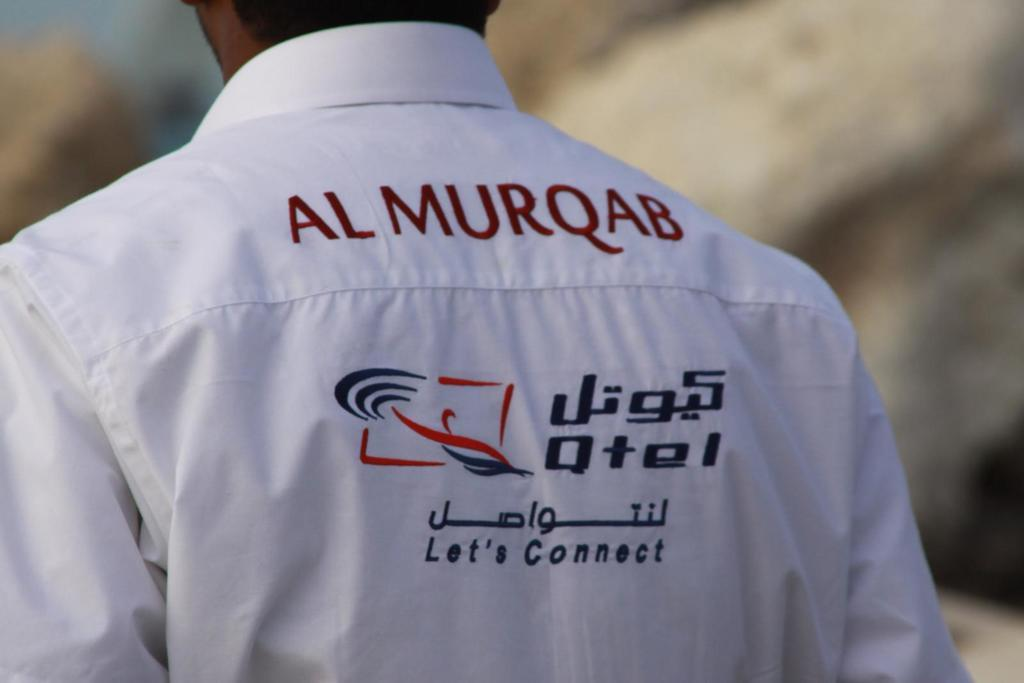Provide a one-sentence caption for the provided image. Almurqab written on the back of a shirt worn by a man with a logo below that states lets connect. 